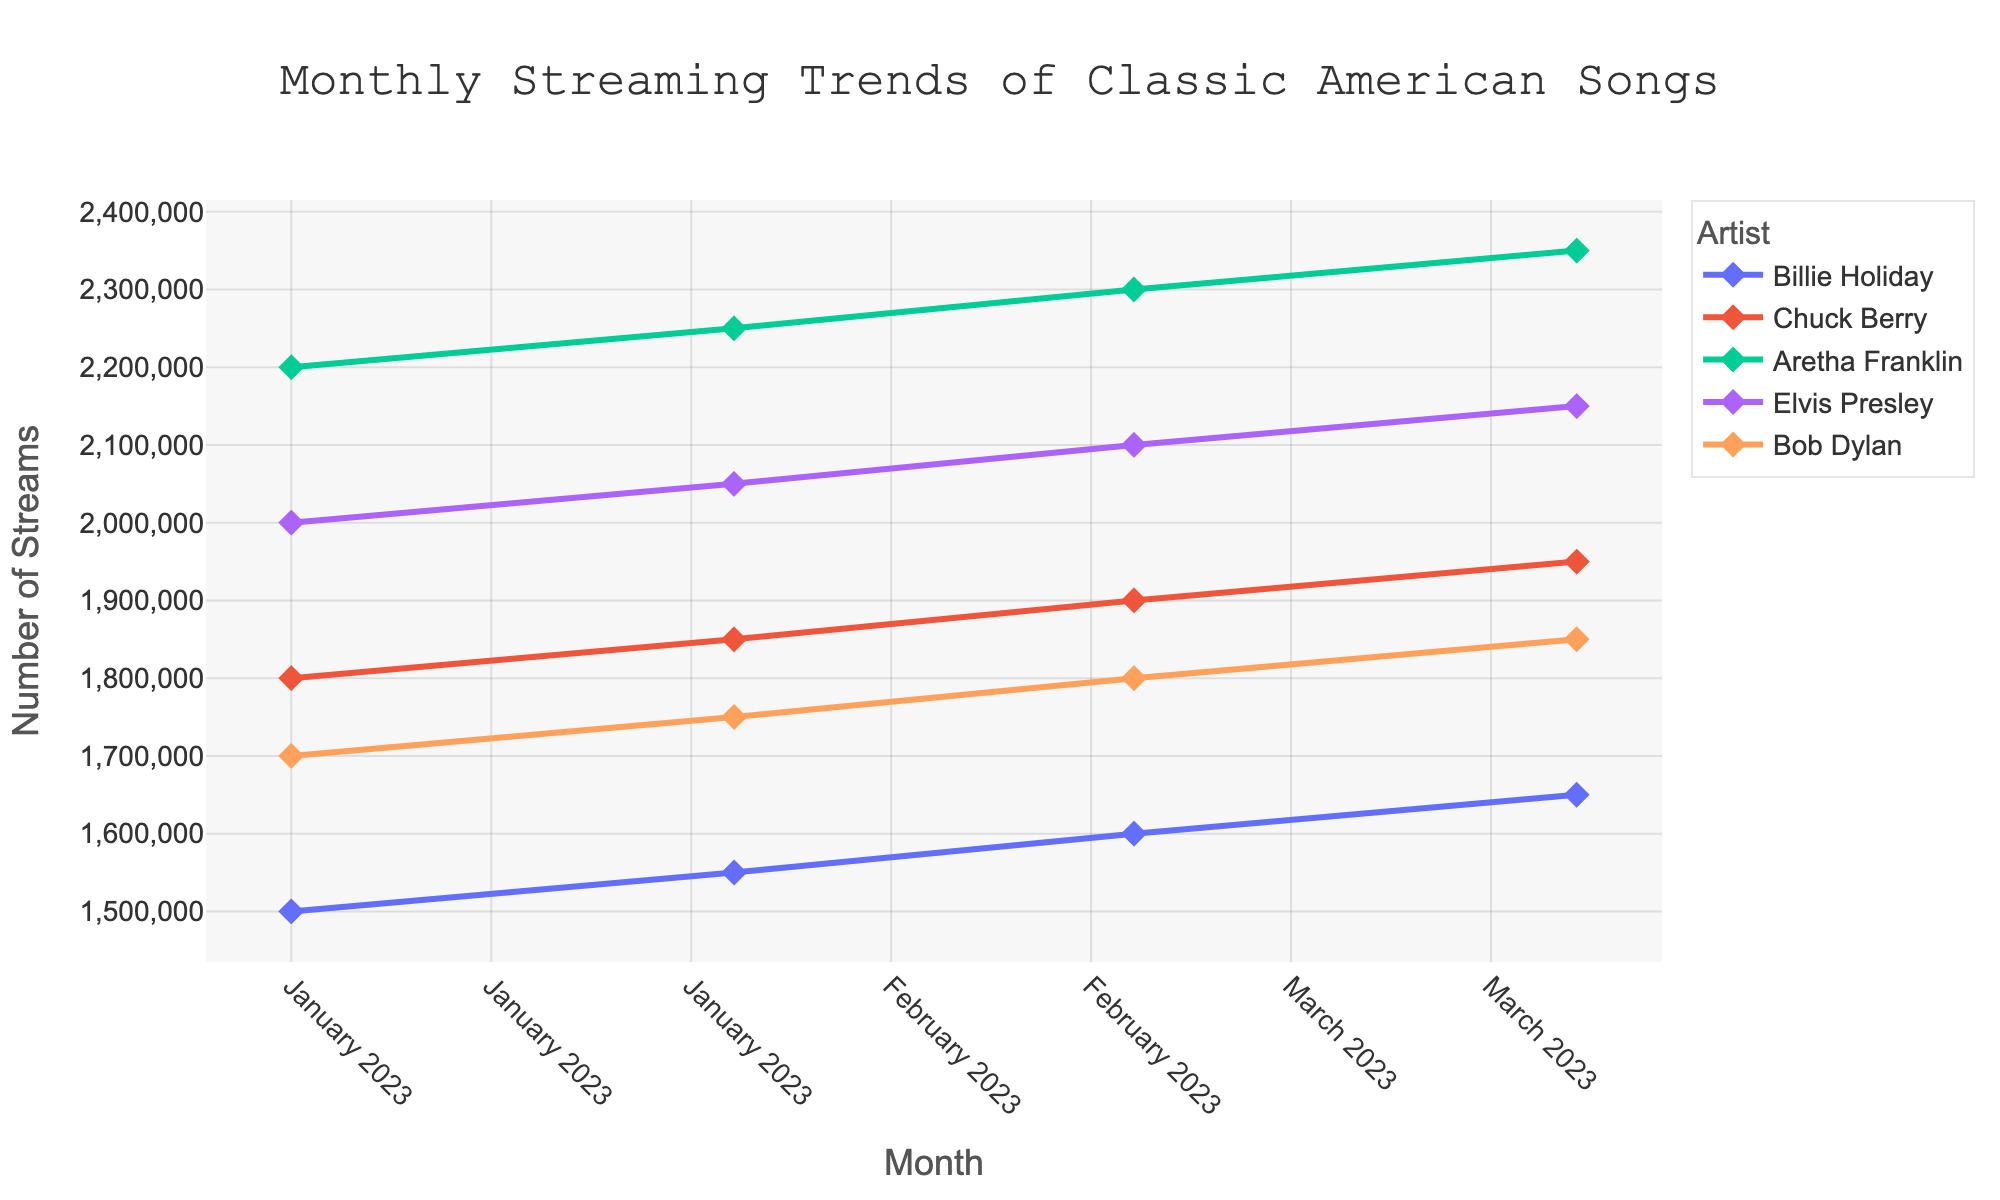What is the title of the time series plot? The title is the text placed at the top which summarizes what the plot is about. From the given description, the title is "Monthly Streaming Trends of Classic American Songs".
Answer: Monthly Streaming Trends of Classic American Songs Which artist has the highest number of streams in April 2023? Look for the artist whose data point is the highest in April 2023. Aretha Franklin's "Respect" has the highest number of streams with 2,350,000.
Answer: Aretha Franklin What is the trend in the number of streams for Bob Dylan's song "Like a Rolling Stone" from January to April 2023? Bob Dylan's streams for "Like a Rolling Stone" show a steady increase over the months: January (1,700,000), February (1,750,000), March (1,800,000), and April (1,850,000).
Answer: Increasing Among the listed songs, which one shows the smallest increase in the number of streams from January to April 2023? Calculate the difference in streams for each song between January and April: (1,650,000 - 1,500,000) for Billie Holiday, (1,950,000 - 1,800,000) for Chuck Berry, (2,350,000 - 2,200,000) for Aretha Franklin, (2,150,000 - 2,000,000) for Elvis Presley, and (1,850,000 - 1,700,000) for Bob Dylan. The smallest increase is for Chuck Berry's "Johnny B. Goode".
Answer: Chuck Berry How many total streams did “Strange Fruit” by Billie Holiday accumulate from January to April 2023? Sum the number of streams for "Strange Fruit" over the four months: 1,500,000 (Jan) + 1,550,000 (Feb) + 1,600,000 (Mar) + 1,650,000 (Apr) = 6,300,000.
Answer: 6,300,000 Which song had the most significant growth in streams from January to April 2023? Calculate the difference in streams for each song between January and April. "Respect" by Aretha Franklin showed the largest increase: 2,350,000 (Apr) - 2,200,000 (Jan) = 150,000.
Answer: Respect Are there any months where the number of streams for any song decreased when compared to the previous month? By examining the streaming numbers month-by-month for each song, there is no month where streams in any category have decreased; they all show an increasing trend.
Answer: No What is the average number of streams for Elvis Presley's song "Can't Help Falling in Love" between January and April 2023? The average is calculated by summing the streams and dividing by the number of data points: (2,000,000 + 2,050,000 + 2,100,000 + 2,150,000) / 4 = 8,300,000 / 4 = 2,075,000.
Answer: 2,075,000 Which artist had the second-highest number of streams in March 2023? Identify each artist’s streams in March: Billie Holiday (1,600,000), Chuck Berry (1,900,000), Aretha Franklin (2,300,000), Elvis Presley (2,100,000), Bob Dylan (1,800,000). Elvis Presley with 2,100,000 streams is second after Aretha Franklin.
Answer: Elvis Presley 